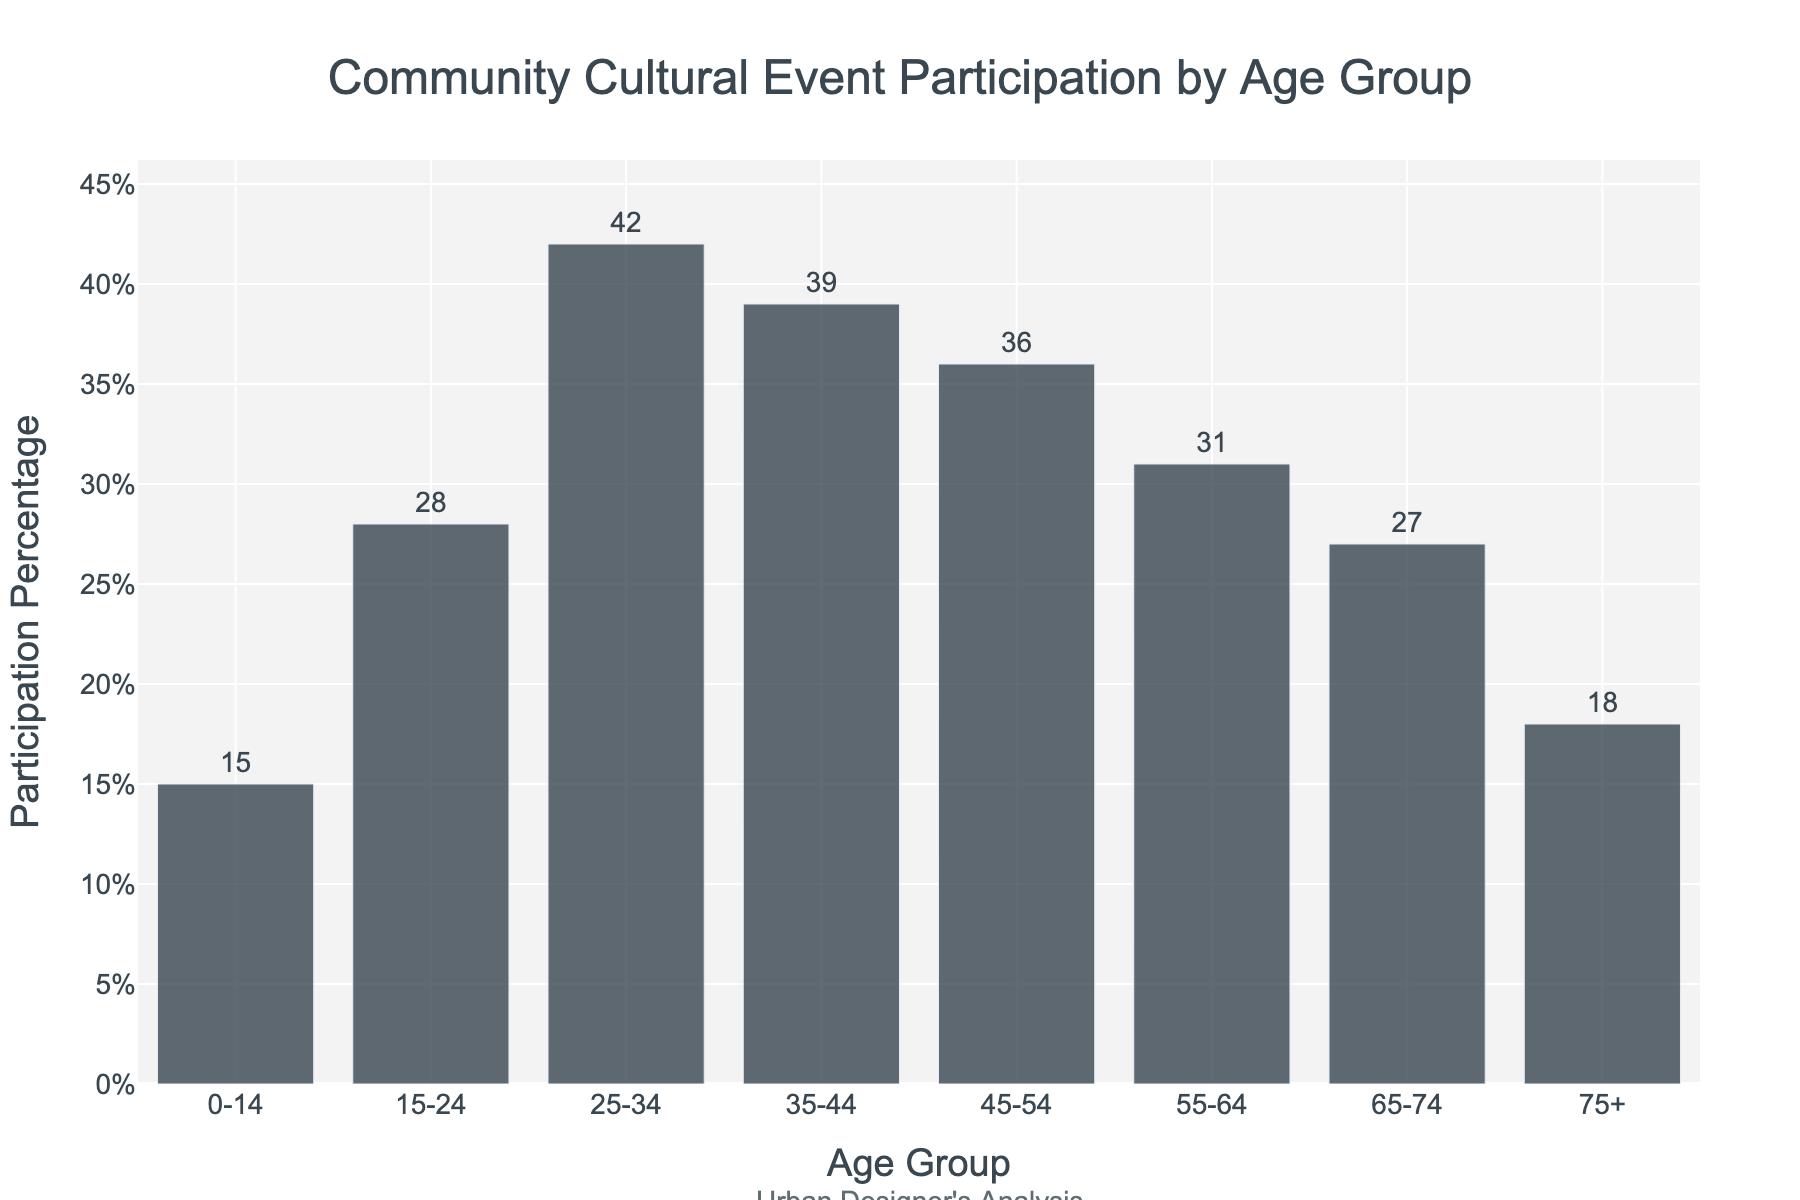What is the age group with the highest participation percentage in community cultural events? By visually inspecting the heights of the bars, we can determine the age groups and compare their participation percentages. The tallest bar represents the highest participation percentage. For the given data, the 25-34 age group has the highest bar height at 42%.
Answer: 25-34 Which age group has a lower participation percentage, 35-44 or 45-54? To find out which age group has a lower participation percentage, compare the heights of the bars for the 35-44 and 45-54 age groups. The 45-54 age group has a shorter bar representing 36%, whereas the 35-44 age group has a taller bar representing 39%. Therefore, the 45-54 age group has a lower participation percentage.
Answer: 45-54 Which two consecutive age groups have the largest difference in participation percentage? Examine the differences in participation percentages between consecutive age groups by comparing the heights of the adjoining bars. The difference between the 25-34 and 35-44 age groups is 42% - 39% = 3%. Check others similarly: 28% to 15% is 13%, 42% to 28% is 14%, 36% to 39% is 3%, 27% to 31% is 4%, and 18% to 27% is 9%. The largest found so far is between 25-34 and 15-24 at 14%.
Answer: 15-24 and 25-34 Calculate the average participation percentage for the age groups 0-14, 15-24, and 25-34. First, find the participation percentages for each group: 0-14 is 15%, 15-24 is 28%, and 25-34 is 42%. Sum these percentages (15 + 28 + 42 = 85) and then divide by the number of groups (3): 85 / 3 = 28.33%.
Answer: 28.33% Which age group shows a participation percentage closest to the average of all age groups? Calculate the average percentage across all age groups. Sum all percentages (15 + 28 + 42 + 39 + 36 + 31 + 27 + 18 = 236) and divide by the number of groups (8). This gives 236 / 8 = 29.5%. The age group closest to 29.5% is 15-24 with 28%.
Answer: 15-24 Compare the total participation percentage of residents aged 15-44 to those aged 45+. Which is higher? First sum the participation percentages for the 15-44 groups: 15-24 (28%) + 25-34 (42%) + 35-44 (39%) = 109%. Then sum for the 45+ groups: 45-54 (36%) + 55-64 (31%) + 65-74 (27%) + 75+ (18%) = 112%. Compare the totals: 112% (45+) is higher than 109% (15-44).
Answer: 45+ What is the total participation percentage for the age groups below 55 years? Add the participation percentages for the groups below 55 years of age: 0-14 (15%), 15-24 (28%), 25-34 (42%), 35-44 (39%), and 45-54 (36%). The total is 15 + 28 + 42 + 39 + 36 = 160%.
Answer: 160% Which age group's participation percentage  is exactly three quarters of the 25-34 age group's? Calculate 3/4 of the 25-34 age group's percentage: (3/4) * 42% = 31.5%. The closest age group's percentage is the 55-64 group at 31%.
Answer: 55-64 What is the difference between the participation percentages of the youngest (0-14) and the oldest (75+) age groups? Find the participation percentages for the youngest (0-14 is 15%) and the oldest (75+ is 18%) groups. Then calculate the difference: 18% - 15% = 3%.
Answer: 3% Which age group's participation percentage lies between the average participation percentages of the age groups 0-14 and 55-64? First, average the percentages for 0-14 (15%) and 55-64 (31%): (15% + 31%) / 2 = 23%. The age group with a participation percentage closest to 23% is 15-24, with 28%.
Answer: 15-24 